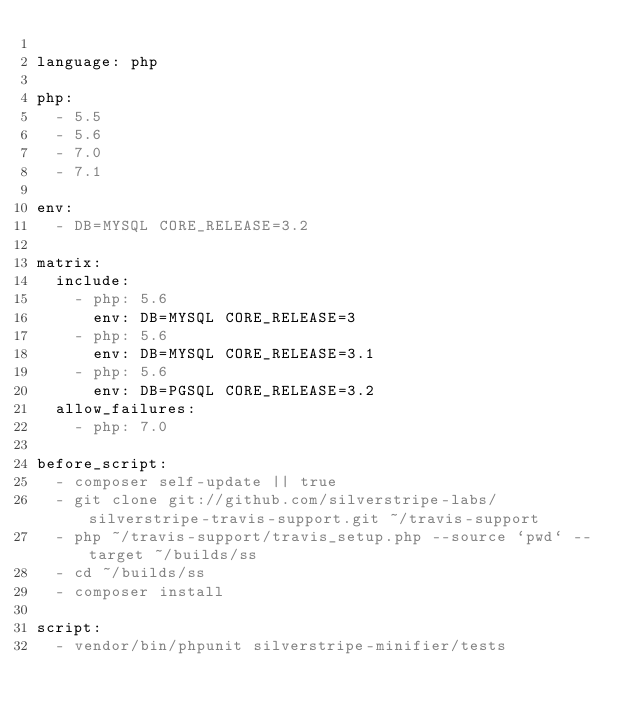<code> <loc_0><loc_0><loc_500><loc_500><_YAML_>
language: php

php:
  - 5.5
  - 5.6
  - 7.0
  - 7.1

env:
  - DB=MYSQL CORE_RELEASE=3.2

matrix:
  include:
    - php: 5.6
      env: DB=MYSQL CORE_RELEASE=3
    - php: 5.6
      env: DB=MYSQL CORE_RELEASE=3.1
    - php: 5.6
      env: DB=PGSQL CORE_RELEASE=3.2
  allow_failures:
    - php: 7.0

before_script:
  - composer self-update || true
  - git clone git://github.com/silverstripe-labs/silverstripe-travis-support.git ~/travis-support
  - php ~/travis-support/travis_setup.php --source `pwd` --target ~/builds/ss
  - cd ~/builds/ss
  - composer install

script:
  - vendor/bin/phpunit silverstripe-minifier/tests
</code> 